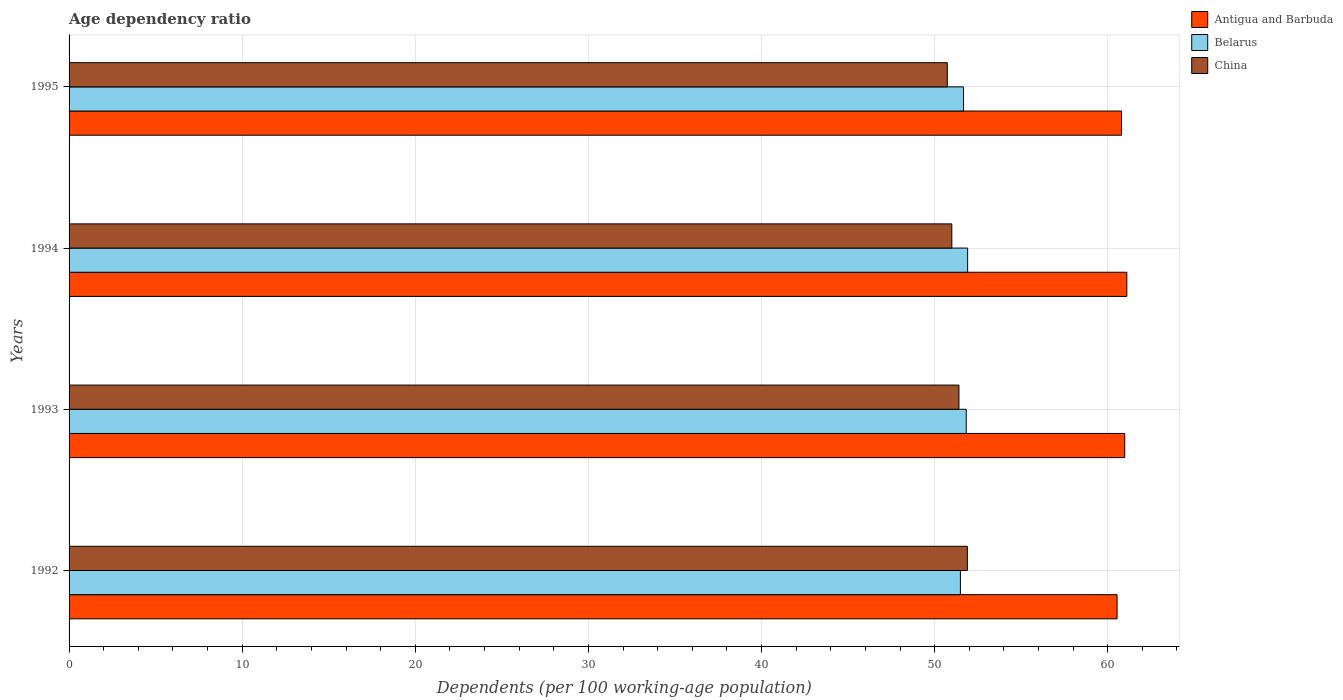How many groups of bars are there?
Keep it short and to the point. 4. How many bars are there on the 4th tick from the top?
Provide a short and direct response. 3. How many bars are there on the 4th tick from the bottom?
Provide a succinct answer. 3. What is the label of the 1st group of bars from the top?
Offer a very short reply. 1995. In how many cases, is the number of bars for a given year not equal to the number of legend labels?
Offer a very short reply. 0. What is the age dependency ratio in in Belarus in 1993?
Offer a very short reply. 51.83. Across all years, what is the maximum age dependency ratio in in Antigua and Barbuda?
Give a very brief answer. 61.1. Across all years, what is the minimum age dependency ratio in in Antigua and Barbuda?
Ensure brevity in your answer.  60.54. What is the total age dependency ratio in in China in the graph?
Your answer should be compact. 205.02. What is the difference between the age dependency ratio in in Antigua and Barbuda in 1993 and that in 1995?
Give a very brief answer. 0.19. What is the difference between the age dependency ratio in in Antigua and Barbuda in 1994 and the age dependency ratio in in China in 1995?
Ensure brevity in your answer.  10.37. What is the average age dependency ratio in in Belarus per year?
Provide a short and direct response. 51.72. In the year 1995, what is the difference between the age dependency ratio in in Belarus and age dependency ratio in in Antigua and Barbuda?
Your answer should be very brief. -9.13. In how many years, is the age dependency ratio in in Belarus greater than 30 %?
Keep it short and to the point. 4. What is the ratio of the age dependency ratio in in Antigua and Barbuda in 1992 to that in 1994?
Your response must be concise. 0.99. Is the age dependency ratio in in Antigua and Barbuda in 1992 less than that in 1993?
Your answer should be very brief. Yes. What is the difference between the highest and the second highest age dependency ratio in in Antigua and Barbuda?
Ensure brevity in your answer.  0.12. What is the difference between the highest and the lowest age dependency ratio in in China?
Your answer should be very brief. 1.16. What does the 1st bar from the top in 1995 represents?
Make the answer very short. China. What does the 2nd bar from the bottom in 1993 represents?
Provide a short and direct response. Belarus. Are all the bars in the graph horizontal?
Ensure brevity in your answer.  Yes. What is the difference between two consecutive major ticks on the X-axis?
Your answer should be very brief. 10. Where does the legend appear in the graph?
Ensure brevity in your answer.  Top right. What is the title of the graph?
Keep it short and to the point. Age dependency ratio. What is the label or title of the X-axis?
Keep it short and to the point. Dependents (per 100 working-age population). What is the label or title of the Y-axis?
Your answer should be very brief. Years. What is the Dependents (per 100 working-age population) of Antigua and Barbuda in 1992?
Your answer should be very brief. 60.54. What is the Dependents (per 100 working-age population) of Belarus in 1992?
Provide a succinct answer. 51.49. What is the Dependents (per 100 working-age population) in China in 1992?
Make the answer very short. 51.89. What is the Dependents (per 100 working-age population) of Antigua and Barbuda in 1993?
Keep it short and to the point. 60.98. What is the Dependents (per 100 working-age population) in Belarus in 1993?
Ensure brevity in your answer.  51.83. What is the Dependents (per 100 working-age population) in China in 1993?
Your answer should be very brief. 51.4. What is the Dependents (per 100 working-age population) in Antigua and Barbuda in 1994?
Make the answer very short. 61.1. What is the Dependents (per 100 working-age population) in Belarus in 1994?
Your answer should be compact. 51.91. What is the Dependents (per 100 working-age population) in China in 1994?
Provide a short and direct response. 50.99. What is the Dependents (per 100 working-age population) in Antigua and Barbuda in 1995?
Ensure brevity in your answer.  60.79. What is the Dependents (per 100 working-age population) of Belarus in 1995?
Provide a succinct answer. 51.67. What is the Dependents (per 100 working-age population) in China in 1995?
Ensure brevity in your answer.  50.73. Across all years, what is the maximum Dependents (per 100 working-age population) in Antigua and Barbuda?
Give a very brief answer. 61.1. Across all years, what is the maximum Dependents (per 100 working-age population) of Belarus?
Give a very brief answer. 51.91. Across all years, what is the maximum Dependents (per 100 working-age population) in China?
Ensure brevity in your answer.  51.89. Across all years, what is the minimum Dependents (per 100 working-age population) of Antigua and Barbuda?
Your answer should be compact. 60.54. Across all years, what is the minimum Dependents (per 100 working-age population) of Belarus?
Provide a short and direct response. 51.49. Across all years, what is the minimum Dependents (per 100 working-age population) in China?
Offer a terse response. 50.73. What is the total Dependents (per 100 working-age population) of Antigua and Barbuda in the graph?
Ensure brevity in your answer.  243.42. What is the total Dependents (per 100 working-age population) in Belarus in the graph?
Make the answer very short. 206.89. What is the total Dependents (per 100 working-age population) of China in the graph?
Make the answer very short. 205.02. What is the difference between the Dependents (per 100 working-age population) in Antigua and Barbuda in 1992 and that in 1993?
Your answer should be compact. -0.44. What is the difference between the Dependents (per 100 working-age population) in Belarus in 1992 and that in 1993?
Provide a short and direct response. -0.34. What is the difference between the Dependents (per 100 working-age population) in China in 1992 and that in 1993?
Your answer should be compact. 0.49. What is the difference between the Dependents (per 100 working-age population) in Antigua and Barbuda in 1992 and that in 1994?
Keep it short and to the point. -0.56. What is the difference between the Dependents (per 100 working-age population) of Belarus in 1992 and that in 1994?
Make the answer very short. -0.42. What is the difference between the Dependents (per 100 working-age population) in China in 1992 and that in 1994?
Your answer should be compact. 0.9. What is the difference between the Dependents (per 100 working-age population) in Antigua and Barbuda in 1992 and that in 1995?
Offer a very short reply. -0.26. What is the difference between the Dependents (per 100 working-age population) of Belarus in 1992 and that in 1995?
Provide a succinct answer. -0.18. What is the difference between the Dependents (per 100 working-age population) of China in 1992 and that in 1995?
Provide a succinct answer. 1.16. What is the difference between the Dependents (per 100 working-age population) of Antigua and Barbuda in 1993 and that in 1994?
Make the answer very short. -0.12. What is the difference between the Dependents (per 100 working-age population) in Belarus in 1993 and that in 1994?
Your answer should be very brief. -0.08. What is the difference between the Dependents (per 100 working-age population) in China in 1993 and that in 1994?
Your answer should be very brief. 0.41. What is the difference between the Dependents (per 100 working-age population) of Antigua and Barbuda in 1993 and that in 1995?
Your answer should be very brief. 0.19. What is the difference between the Dependents (per 100 working-age population) of Belarus in 1993 and that in 1995?
Your response must be concise. 0.16. What is the difference between the Dependents (per 100 working-age population) in China in 1993 and that in 1995?
Your answer should be compact. 0.67. What is the difference between the Dependents (per 100 working-age population) of Antigua and Barbuda in 1994 and that in 1995?
Keep it short and to the point. 0.31. What is the difference between the Dependents (per 100 working-age population) in Belarus in 1994 and that in 1995?
Keep it short and to the point. 0.24. What is the difference between the Dependents (per 100 working-age population) in China in 1994 and that in 1995?
Make the answer very short. 0.26. What is the difference between the Dependents (per 100 working-age population) of Antigua and Barbuda in 1992 and the Dependents (per 100 working-age population) of Belarus in 1993?
Offer a terse response. 8.71. What is the difference between the Dependents (per 100 working-age population) of Antigua and Barbuda in 1992 and the Dependents (per 100 working-age population) of China in 1993?
Make the answer very short. 9.13. What is the difference between the Dependents (per 100 working-age population) of Belarus in 1992 and the Dependents (per 100 working-age population) of China in 1993?
Your answer should be very brief. 0.08. What is the difference between the Dependents (per 100 working-age population) in Antigua and Barbuda in 1992 and the Dependents (per 100 working-age population) in Belarus in 1994?
Your answer should be very brief. 8.63. What is the difference between the Dependents (per 100 working-age population) of Antigua and Barbuda in 1992 and the Dependents (per 100 working-age population) of China in 1994?
Your response must be concise. 9.55. What is the difference between the Dependents (per 100 working-age population) of Belarus in 1992 and the Dependents (per 100 working-age population) of China in 1994?
Offer a terse response. 0.5. What is the difference between the Dependents (per 100 working-age population) in Antigua and Barbuda in 1992 and the Dependents (per 100 working-age population) in Belarus in 1995?
Make the answer very short. 8.87. What is the difference between the Dependents (per 100 working-age population) of Antigua and Barbuda in 1992 and the Dependents (per 100 working-age population) of China in 1995?
Your answer should be very brief. 9.81. What is the difference between the Dependents (per 100 working-age population) of Belarus in 1992 and the Dependents (per 100 working-age population) of China in 1995?
Your answer should be very brief. 0.76. What is the difference between the Dependents (per 100 working-age population) of Antigua and Barbuda in 1993 and the Dependents (per 100 working-age population) of Belarus in 1994?
Your answer should be very brief. 9.08. What is the difference between the Dependents (per 100 working-age population) in Antigua and Barbuda in 1993 and the Dependents (per 100 working-age population) in China in 1994?
Provide a short and direct response. 9.99. What is the difference between the Dependents (per 100 working-age population) in Belarus in 1993 and the Dependents (per 100 working-age population) in China in 1994?
Your answer should be very brief. 0.83. What is the difference between the Dependents (per 100 working-age population) of Antigua and Barbuda in 1993 and the Dependents (per 100 working-age population) of Belarus in 1995?
Your answer should be very brief. 9.31. What is the difference between the Dependents (per 100 working-age population) of Antigua and Barbuda in 1993 and the Dependents (per 100 working-age population) of China in 1995?
Keep it short and to the point. 10.25. What is the difference between the Dependents (per 100 working-age population) of Belarus in 1993 and the Dependents (per 100 working-age population) of China in 1995?
Offer a very short reply. 1.09. What is the difference between the Dependents (per 100 working-age population) of Antigua and Barbuda in 1994 and the Dependents (per 100 working-age population) of Belarus in 1995?
Give a very brief answer. 9.43. What is the difference between the Dependents (per 100 working-age population) in Antigua and Barbuda in 1994 and the Dependents (per 100 working-age population) in China in 1995?
Your answer should be compact. 10.37. What is the difference between the Dependents (per 100 working-age population) of Belarus in 1994 and the Dependents (per 100 working-age population) of China in 1995?
Make the answer very short. 1.17. What is the average Dependents (per 100 working-age population) of Antigua and Barbuda per year?
Your answer should be very brief. 60.85. What is the average Dependents (per 100 working-age population) of Belarus per year?
Give a very brief answer. 51.72. What is the average Dependents (per 100 working-age population) of China per year?
Your answer should be compact. 51.26. In the year 1992, what is the difference between the Dependents (per 100 working-age population) of Antigua and Barbuda and Dependents (per 100 working-age population) of Belarus?
Provide a succinct answer. 9.05. In the year 1992, what is the difference between the Dependents (per 100 working-age population) of Antigua and Barbuda and Dependents (per 100 working-age population) of China?
Provide a succinct answer. 8.65. In the year 1992, what is the difference between the Dependents (per 100 working-age population) in Belarus and Dependents (per 100 working-age population) in China?
Provide a succinct answer. -0.4. In the year 1993, what is the difference between the Dependents (per 100 working-age population) of Antigua and Barbuda and Dependents (per 100 working-age population) of Belarus?
Your answer should be very brief. 9.16. In the year 1993, what is the difference between the Dependents (per 100 working-age population) in Antigua and Barbuda and Dependents (per 100 working-age population) in China?
Ensure brevity in your answer.  9.58. In the year 1993, what is the difference between the Dependents (per 100 working-age population) of Belarus and Dependents (per 100 working-age population) of China?
Offer a very short reply. 0.42. In the year 1994, what is the difference between the Dependents (per 100 working-age population) of Antigua and Barbuda and Dependents (per 100 working-age population) of Belarus?
Provide a succinct answer. 9.2. In the year 1994, what is the difference between the Dependents (per 100 working-age population) of Antigua and Barbuda and Dependents (per 100 working-age population) of China?
Provide a short and direct response. 10.11. In the year 1994, what is the difference between the Dependents (per 100 working-age population) in Belarus and Dependents (per 100 working-age population) in China?
Give a very brief answer. 0.91. In the year 1995, what is the difference between the Dependents (per 100 working-age population) of Antigua and Barbuda and Dependents (per 100 working-age population) of Belarus?
Give a very brief answer. 9.13. In the year 1995, what is the difference between the Dependents (per 100 working-age population) in Antigua and Barbuda and Dependents (per 100 working-age population) in China?
Your answer should be very brief. 10.06. In the year 1995, what is the difference between the Dependents (per 100 working-age population) of Belarus and Dependents (per 100 working-age population) of China?
Offer a very short reply. 0.94. What is the ratio of the Dependents (per 100 working-age population) in China in 1992 to that in 1993?
Make the answer very short. 1.01. What is the ratio of the Dependents (per 100 working-age population) of Antigua and Barbuda in 1992 to that in 1994?
Make the answer very short. 0.99. What is the ratio of the Dependents (per 100 working-age population) in Belarus in 1992 to that in 1994?
Your response must be concise. 0.99. What is the ratio of the Dependents (per 100 working-age population) in China in 1992 to that in 1994?
Ensure brevity in your answer.  1.02. What is the ratio of the Dependents (per 100 working-age population) in China in 1992 to that in 1995?
Give a very brief answer. 1.02. What is the ratio of the Dependents (per 100 working-age population) of China in 1993 to that in 1994?
Give a very brief answer. 1.01. What is the ratio of the Dependents (per 100 working-age population) in Antigua and Barbuda in 1993 to that in 1995?
Your answer should be compact. 1. What is the ratio of the Dependents (per 100 working-age population) in China in 1993 to that in 1995?
Provide a short and direct response. 1.01. What is the ratio of the Dependents (per 100 working-age population) of Belarus in 1994 to that in 1995?
Provide a short and direct response. 1. What is the difference between the highest and the second highest Dependents (per 100 working-age population) in Antigua and Barbuda?
Your response must be concise. 0.12. What is the difference between the highest and the second highest Dependents (per 100 working-age population) of Belarus?
Your answer should be compact. 0.08. What is the difference between the highest and the second highest Dependents (per 100 working-age population) in China?
Offer a very short reply. 0.49. What is the difference between the highest and the lowest Dependents (per 100 working-age population) in Antigua and Barbuda?
Provide a succinct answer. 0.56. What is the difference between the highest and the lowest Dependents (per 100 working-age population) in Belarus?
Offer a terse response. 0.42. What is the difference between the highest and the lowest Dependents (per 100 working-age population) in China?
Provide a succinct answer. 1.16. 